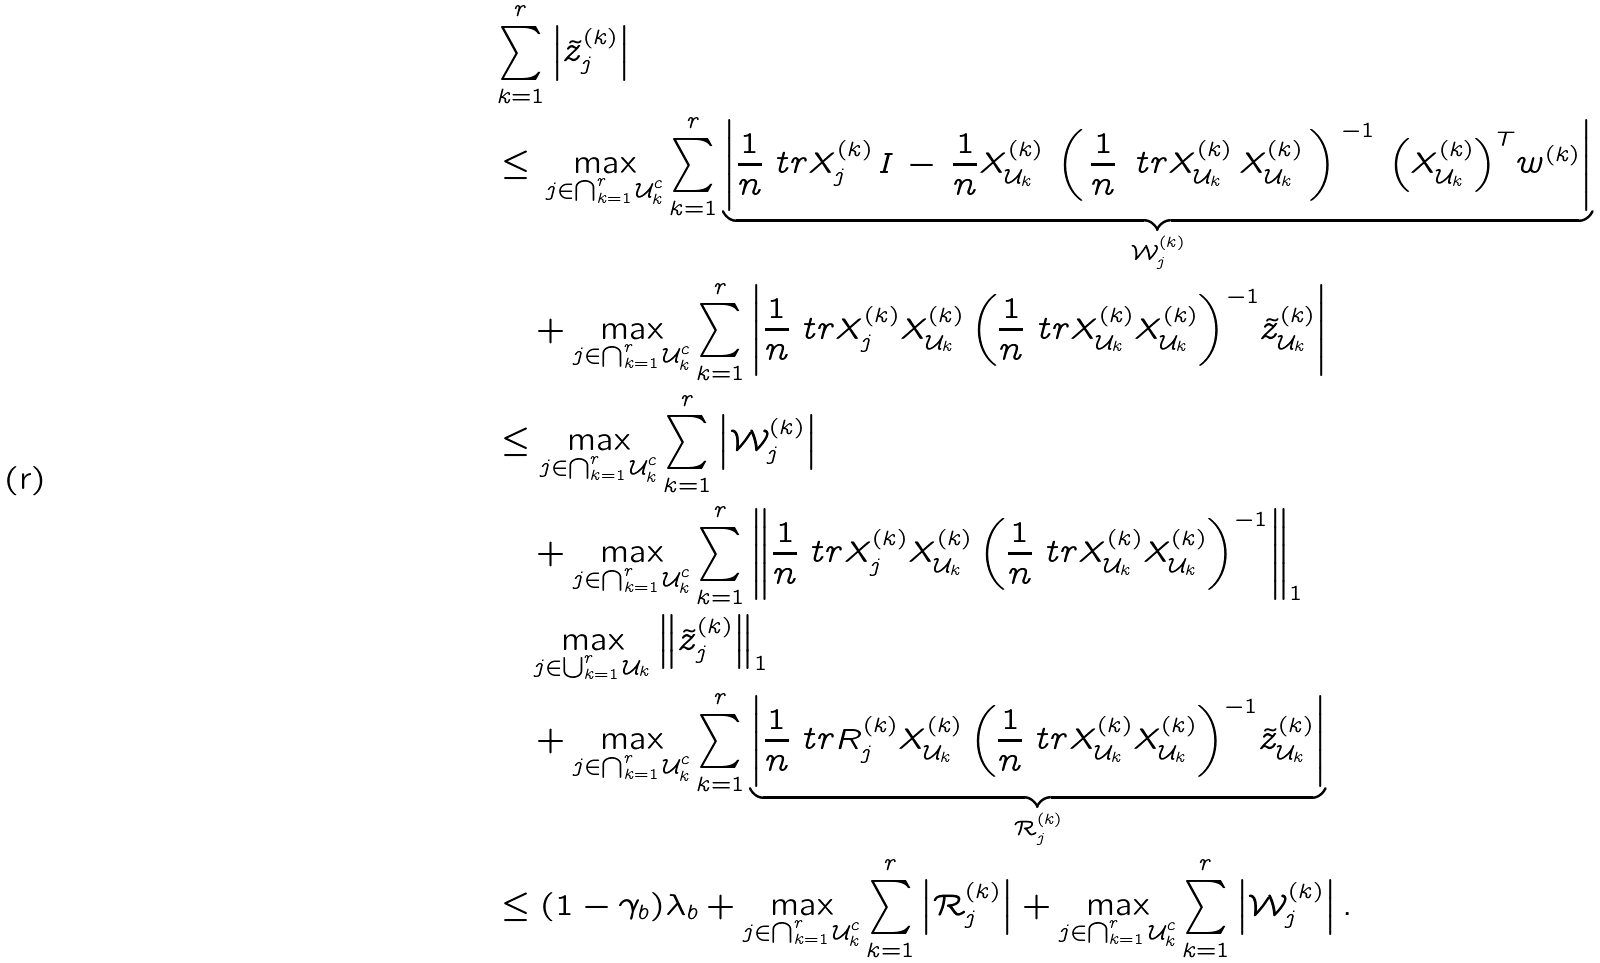Convert formula to latex. <formula><loc_0><loc_0><loc_500><loc_500>& \sum _ { k = 1 } ^ { r } \left | \tilde { z } ^ { ( k ) } _ { j } \right | \\ & \leq \, \max _ { j \in \bigcap _ { k = 1 } ^ { r } \mathcal { U } _ { k } ^ { c } } \sum _ { k = 1 } ^ { r } \underbrace { \left | \frac { 1 } { n } \ t r { X ^ { ( k ) } _ { j } \, } { I \, - \, \frac { 1 } { n } X ^ { ( k ) } _ { \mathcal { U } _ { k } } \, \left ( \, \frac { 1 } { n } \, \ t r { X ^ { ( k ) } _ { \mathcal { U } _ { k } } \, } { X ^ { ( k ) } _ { \mathcal { U } _ { k } } } \, \right ) ^ { \, - 1 } \, \left ( X ^ { ( k ) } _ { \mathcal { U } _ { k } } \right ) ^ { T } } w ^ { ( k ) } \right | } _ { \mathcal { W } _ { j } ^ { ( k ) } } \\ & \quad + \max _ { j \in \bigcap _ { k = 1 } ^ { r } \mathcal { U } _ { k } ^ { c } } \sum _ { k = 1 } ^ { r } \left | \frac { 1 } { n } \ t r { X ^ { ( k ) } _ { j } } { X ^ { ( k ) } _ { \mathcal { U } _ { k } } \left ( \frac { 1 } { n } \ t r { X ^ { ( k ) } _ { \mathcal { U } _ { k } } } { X ^ { ( k ) } _ { \mathcal { U } _ { k } } } \right ) ^ { - 1 } } \tilde { z } ^ { ( k ) } _ { \mathcal { U } _ { k } } \right | \\ & \leq \max _ { j \in \bigcap _ { k = 1 } ^ { r } \mathcal { U } _ { k } ^ { c } } \sum _ { k = 1 } ^ { r } \left | \mathcal { W } _ { j } ^ { ( k ) } \right | \\ & \quad + \max _ { j \in \bigcap _ { k = 1 } ^ { r } \mathcal { U } _ { k } ^ { c } } \sum _ { k = 1 } ^ { r } \left \| \frac { 1 } { n } \ t r { X ^ { ( k ) } _ { j } } { X ^ { ( k ) } _ { \mathcal { U } _ { k } } \left ( \frac { 1 } { n } \ t r { X ^ { ( k ) } _ { \mathcal { U } _ { k } } } { X ^ { ( k ) } _ { \mathcal { U } _ { k } } } \right ) ^ { - 1 } } \right \| _ { 1 } \\ & \quad \max _ { j \in \bigcup _ { k = 1 } ^ { r } \mathcal { U } _ { k } } \left \| \tilde { z } ^ { ( k ) } _ { j } \right \| _ { 1 } \\ & \quad + \max _ { j \in \bigcap _ { k = 1 } ^ { r } \mathcal { U } _ { k } ^ { c } } \sum _ { k = 1 } ^ { r } \underbrace { \left | \frac { 1 } { n } \ t r { R ^ { ( k ) } _ { j } } { X ^ { ( k ) } _ { \mathcal { U } _ { k } } \left ( \frac { 1 } { n } \ t r { X ^ { ( k ) } _ { \mathcal { U } _ { k } } } { X ^ { ( k ) } _ { \mathcal { U } _ { k } } } \right ) ^ { - 1 } } \tilde { z } ^ { ( k ) } _ { \mathcal { U } _ { k } } \right | } _ { \mathcal { R } _ { j } ^ { ( k ) } } \\ & \leq ( 1 - \gamma _ { b } ) \lambda _ { b } + \max _ { j \in \bigcap _ { k = 1 } ^ { r } \mathcal { U } _ { k } ^ { c } } \sum _ { k = 1 } ^ { r } \left | \mathcal { R } _ { j } ^ { ( k ) } \right | + \max _ { j \in \bigcap _ { k = 1 } ^ { r } \mathcal { U } _ { k } ^ { c } } \sum _ { k = 1 } ^ { r } \left | \mathcal { W } _ { j } ^ { ( k ) } \right | . \\</formula> 